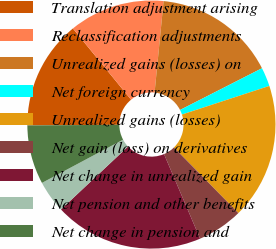Convert chart to OTSL. <chart><loc_0><loc_0><loc_500><loc_500><pie_chart><fcel>Translation adjustment arising<fcel>Reclassification adjustments<fcel>Unrealized gains (losses) on<fcel>Net foreign currency<fcel>Unrealized gains (losses)<fcel>Net gain (loss) on derivatives<fcel>Net change in unrealized gain<fcel>Net pension and other benefits<fcel>Net change in pension and<nl><fcel>14.21%<fcel>12.47%<fcel>15.94%<fcel>2.46%<fcel>17.68%<fcel>5.94%<fcel>19.42%<fcel>4.2%<fcel>7.68%<nl></chart> 